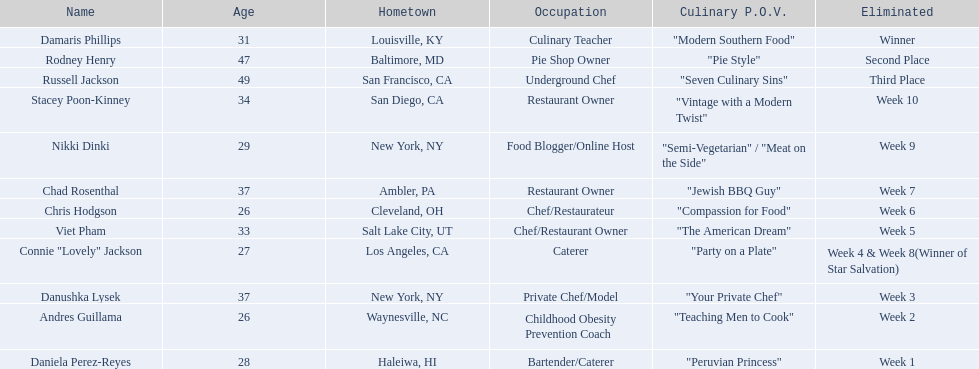Which contender's involvement was limited to two weeks only? Andres Guillama. 